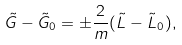<formula> <loc_0><loc_0><loc_500><loc_500>\tilde { G } - \tilde { G } _ { 0 } = \pm \frac { 2 } { m } ( \tilde { L } - \tilde { L } _ { 0 } ) ,</formula> 